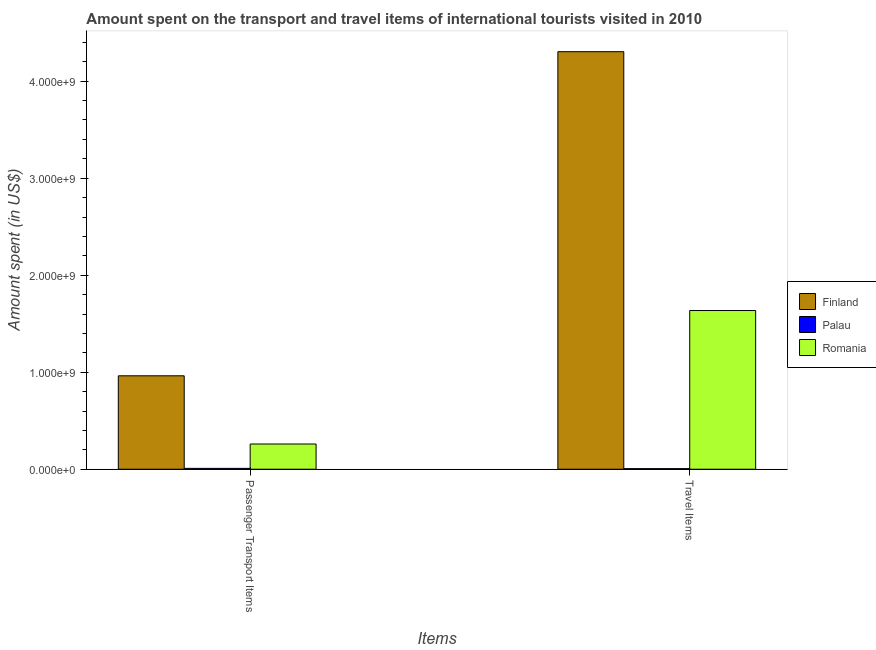How many different coloured bars are there?
Give a very brief answer. 3. How many groups of bars are there?
Provide a succinct answer. 2. Are the number of bars on each tick of the X-axis equal?
Ensure brevity in your answer.  Yes. What is the label of the 2nd group of bars from the left?
Provide a succinct answer. Travel Items. What is the amount spent in travel items in Palau?
Provide a short and direct response. 6.00e+06. Across all countries, what is the maximum amount spent in travel items?
Ensure brevity in your answer.  4.30e+09. Across all countries, what is the minimum amount spent on passenger transport items?
Provide a short and direct response. 8.80e+06. In which country was the amount spent in travel items maximum?
Offer a very short reply. Finland. In which country was the amount spent on passenger transport items minimum?
Keep it short and to the point. Palau. What is the total amount spent on passenger transport items in the graph?
Give a very brief answer. 1.23e+09. What is the difference between the amount spent in travel items in Finland and that in Romania?
Your answer should be very brief. 2.67e+09. What is the difference between the amount spent in travel items in Finland and the amount spent on passenger transport items in Romania?
Your answer should be compact. 4.04e+09. What is the average amount spent on passenger transport items per country?
Your answer should be very brief. 4.11e+08. What is the difference between the amount spent on passenger transport items and amount spent in travel items in Romania?
Offer a terse response. -1.38e+09. What is the ratio of the amount spent in travel items in Finland to that in Palau?
Provide a succinct answer. 717.33. Is the amount spent in travel items in Finland less than that in Palau?
Your answer should be compact. No. In how many countries, is the amount spent on passenger transport items greater than the average amount spent on passenger transport items taken over all countries?
Keep it short and to the point. 1. What does the 3rd bar from the left in Passenger Transport Items represents?
Your response must be concise. Romania. How many countries are there in the graph?
Provide a succinct answer. 3. Does the graph contain grids?
Your answer should be compact. No. How are the legend labels stacked?
Your answer should be compact. Vertical. What is the title of the graph?
Offer a very short reply. Amount spent on the transport and travel items of international tourists visited in 2010. What is the label or title of the X-axis?
Your response must be concise. Items. What is the label or title of the Y-axis?
Your answer should be compact. Amount spent (in US$). What is the Amount spent (in US$) in Finland in Passenger Transport Items?
Provide a short and direct response. 9.63e+08. What is the Amount spent (in US$) in Palau in Passenger Transport Items?
Your answer should be compact. 8.80e+06. What is the Amount spent (in US$) of Romania in Passenger Transport Items?
Offer a very short reply. 2.60e+08. What is the Amount spent (in US$) of Finland in Travel Items?
Ensure brevity in your answer.  4.30e+09. What is the Amount spent (in US$) in Romania in Travel Items?
Ensure brevity in your answer.  1.64e+09. Across all Items, what is the maximum Amount spent (in US$) in Finland?
Provide a short and direct response. 4.30e+09. Across all Items, what is the maximum Amount spent (in US$) in Palau?
Provide a short and direct response. 8.80e+06. Across all Items, what is the maximum Amount spent (in US$) of Romania?
Ensure brevity in your answer.  1.64e+09. Across all Items, what is the minimum Amount spent (in US$) in Finland?
Your answer should be compact. 9.63e+08. Across all Items, what is the minimum Amount spent (in US$) of Romania?
Offer a very short reply. 2.60e+08. What is the total Amount spent (in US$) in Finland in the graph?
Offer a very short reply. 5.27e+09. What is the total Amount spent (in US$) of Palau in the graph?
Provide a succinct answer. 1.48e+07. What is the total Amount spent (in US$) in Romania in the graph?
Your answer should be compact. 1.90e+09. What is the difference between the Amount spent (in US$) of Finland in Passenger Transport Items and that in Travel Items?
Offer a terse response. -3.34e+09. What is the difference between the Amount spent (in US$) of Palau in Passenger Transport Items and that in Travel Items?
Provide a short and direct response. 2.80e+06. What is the difference between the Amount spent (in US$) of Romania in Passenger Transport Items and that in Travel Items?
Your answer should be very brief. -1.38e+09. What is the difference between the Amount spent (in US$) in Finland in Passenger Transport Items and the Amount spent (in US$) in Palau in Travel Items?
Provide a short and direct response. 9.57e+08. What is the difference between the Amount spent (in US$) of Finland in Passenger Transport Items and the Amount spent (in US$) of Romania in Travel Items?
Make the answer very short. -6.73e+08. What is the difference between the Amount spent (in US$) of Palau in Passenger Transport Items and the Amount spent (in US$) of Romania in Travel Items?
Offer a very short reply. -1.63e+09. What is the average Amount spent (in US$) of Finland per Items?
Provide a succinct answer. 2.63e+09. What is the average Amount spent (in US$) of Palau per Items?
Offer a terse response. 7.40e+06. What is the average Amount spent (in US$) in Romania per Items?
Provide a succinct answer. 9.48e+08. What is the difference between the Amount spent (in US$) in Finland and Amount spent (in US$) in Palau in Passenger Transport Items?
Make the answer very short. 9.54e+08. What is the difference between the Amount spent (in US$) of Finland and Amount spent (in US$) of Romania in Passenger Transport Items?
Give a very brief answer. 7.03e+08. What is the difference between the Amount spent (in US$) of Palau and Amount spent (in US$) of Romania in Passenger Transport Items?
Your answer should be very brief. -2.51e+08. What is the difference between the Amount spent (in US$) in Finland and Amount spent (in US$) in Palau in Travel Items?
Your answer should be very brief. 4.30e+09. What is the difference between the Amount spent (in US$) in Finland and Amount spent (in US$) in Romania in Travel Items?
Your response must be concise. 2.67e+09. What is the difference between the Amount spent (in US$) of Palau and Amount spent (in US$) of Romania in Travel Items?
Offer a very short reply. -1.63e+09. What is the ratio of the Amount spent (in US$) in Finland in Passenger Transport Items to that in Travel Items?
Offer a terse response. 0.22. What is the ratio of the Amount spent (in US$) of Palau in Passenger Transport Items to that in Travel Items?
Provide a succinct answer. 1.47. What is the ratio of the Amount spent (in US$) in Romania in Passenger Transport Items to that in Travel Items?
Offer a very short reply. 0.16. What is the difference between the highest and the second highest Amount spent (in US$) of Finland?
Your response must be concise. 3.34e+09. What is the difference between the highest and the second highest Amount spent (in US$) of Palau?
Offer a terse response. 2.80e+06. What is the difference between the highest and the second highest Amount spent (in US$) in Romania?
Offer a very short reply. 1.38e+09. What is the difference between the highest and the lowest Amount spent (in US$) in Finland?
Offer a very short reply. 3.34e+09. What is the difference between the highest and the lowest Amount spent (in US$) of Palau?
Your response must be concise. 2.80e+06. What is the difference between the highest and the lowest Amount spent (in US$) in Romania?
Offer a very short reply. 1.38e+09. 